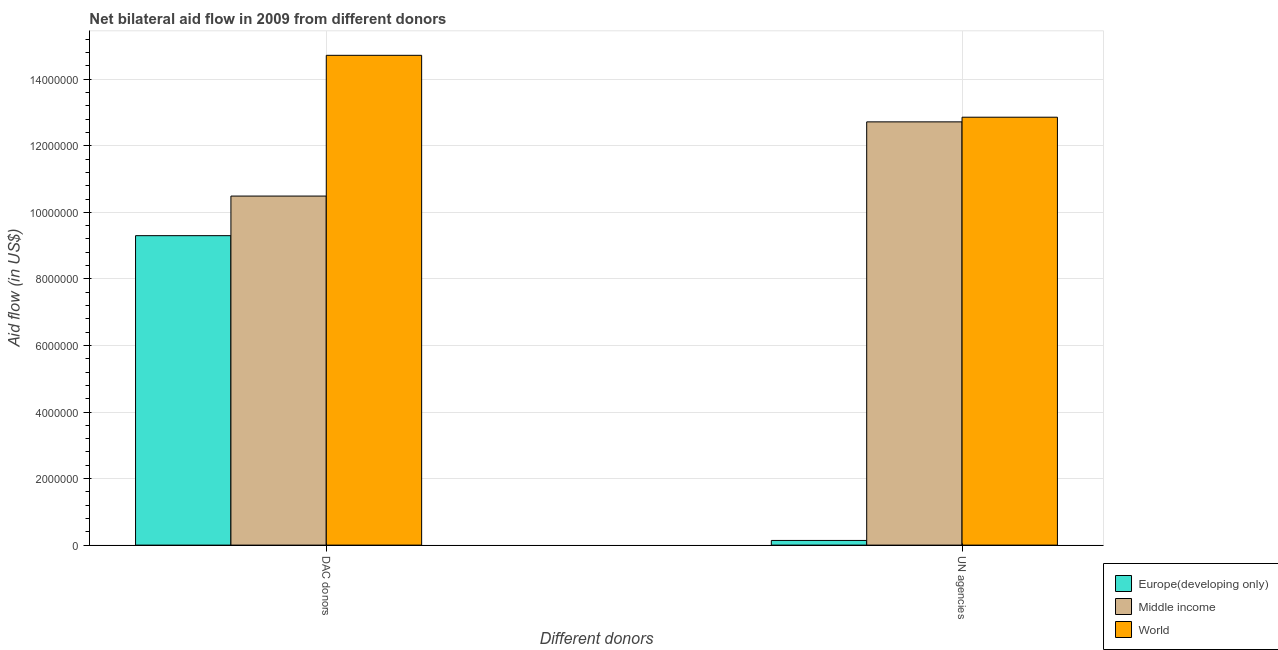How many groups of bars are there?
Your response must be concise. 2. Are the number of bars per tick equal to the number of legend labels?
Make the answer very short. Yes. How many bars are there on the 1st tick from the left?
Offer a terse response. 3. How many bars are there on the 1st tick from the right?
Provide a short and direct response. 3. What is the label of the 2nd group of bars from the left?
Give a very brief answer. UN agencies. What is the aid flow from un agencies in Europe(developing only)?
Keep it short and to the point. 1.40e+05. Across all countries, what is the maximum aid flow from dac donors?
Provide a succinct answer. 1.47e+07. Across all countries, what is the minimum aid flow from dac donors?
Provide a short and direct response. 9.30e+06. In which country was the aid flow from un agencies minimum?
Make the answer very short. Europe(developing only). What is the total aid flow from dac donors in the graph?
Give a very brief answer. 3.45e+07. What is the difference between the aid flow from dac donors in World and that in Europe(developing only)?
Your response must be concise. 5.42e+06. What is the difference between the aid flow from dac donors in Europe(developing only) and the aid flow from un agencies in Middle income?
Keep it short and to the point. -3.42e+06. What is the average aid flow from dac donors per country?
Give a very brief answer. 1.15e+07. What is the difference between the aid flow from dac donors and aid flow from un agencies in World?
Give a very brief answer. 1.86e+06. What is the ratio of the aid flow from dac donors in World to that in Europe(developing only)?
Make the answer very short. 1.58. Is the aid flow from un agencies in World less than that in Middle income?
Offer a very short reply. No. What does the 3rd bar from the left in DAC donors represents?
Keep it short and to the point. World. What does the 1st bar from the right in DAC donors represents?
Your response must be concise. World. Are all the bars in the graph horizontal?
Your answer should be very brief. No. Are the values on the major ticks of Y-axis written in scientific E-notation?
Keep it short and to the point. No. Does the graph contain any zero values?
Offer a very short reply. No. Does the graph contain grids?
Your answer should be compact. Yes. What is the title of the graph?
Offer a very short reply. Net bilateral aid flow in 2009 from different donors. What is the label or title of the X-axis?
Your answer should be very brief. Different donors. What is the label or title of the Y-axis?
Provide a short and direct response. Aid flow (in US$). What is the Aid flow (in US$) in Europe(developing only) in DAC donors?
Offer a terse response. 9.30e+06. What is the Aid flow (in US$) of Middle income in DAC donors?
Offer a very short reply. 1.05e+07. What is the Aid flow (in US$) of World in DAC donors?
Offer a very short reply. 1.47e+07. What is the Aid flow (in US$) in Middle income in UN agencies?
Keep it short and to the point. 1.27e+07. What is the Aid flow (in US$) in World in UN agencies?
Provide a short and direct response. 1.29e+07. Across all Different donors, what is the maximum Aid flow (in US$) in Europe(developing only)?
Make the answer very short. 9.30e+06. Across all Different donors, what is the maximum Aid flow (in US$) in Middle income?
Offer a terse response. 1.27e+07. Across all Different donors, what is the maximum Aid flow (in US$) in World?
Provide a succinct answer. 1.47e+07. Across all Different donors, what is the minimum Aid flow (in US$) of Europe(developing only)?
Your answer should be very brief. 1.40e+05. Across all Different donors, what is the minimum Aid flow (in US$) in Middle income?
Provide a short and direct response. 1.05e+07. Across all Different donors, what is the minimum Aid flow (in US$) in World?
Give a very brief answer. 1.29e+07. What is the total Aid flow (in US$) of Europe(developing only) in the graph?
Make the answer very short. 9.44e+06. What is the total Aid flow (in US$) of Middle income in the graph?
Offer a terse response. 2.32e+07. What is the total Aid flow (in US$) in World in the graph?
Make the answer very short. 2.76e+07. What is the difference between the Aid flow (in US$) of Europe(developing only) in DAC donors and that in UN agencies?
Offer a very short reply. 9.16e+06. What is the difference between the Aid flow (in US$) of Middle income in DAC donors and that in UN agencies?
Provide a succinct answer. -2.23e+06. What is the difference between the Aid flow (in US$) of World in DAC donors and that in UN agencies?
Provide a succinct answer. 1.86e+06. What is the difference between the Aid flow (in US$) of Europe(developing only) in DAC donors and the Aid flow (in US$) of Middle income in UN agencies?
Provide a succinct answer. -3.42e+06. What is the difference between the Aid flow (in US$) of Europe(developing only) in DAC donors and the Aid flow (in US$) of World in UN agencies?
Offer a very short reply. -3.56e+06. What is the difference between the Aid flow (in US$) of Middle income in DAC donors and the Aid flow (in US$) of World in UN agencies?
Provide a succinct answer. -2.37e+06. What is the average Aid flow (in US$) of Europe(developing only) per Different donors?
Provide a succinct answer. 4.72e+06. What is the average Aid flow (in US$) of Middle income per Different donors?
Offer a terse response. 1.16e+07. What is the average Aid flow (in US$) of World per Different donors?
Your answer should be compact. 1.38e+07. What is the difference between the Aid flow (in US$) of Europe(developing only) and Aid flow (in US$) of Middle income in DAC donors?
Provide a short and direct response. -1.19e+06. What is the difference between the Aid flow (in US$) of Europe(developing only) and Aid flow (in US$) of World in DAC donors?
Give a very brief answer. -5.42e+06. What is the difference between the Aid flow (in US$) in Middle income and Aid flow (in US$) in World in DAC donors?
Keep it short and to the point. -4.23e+06. What is the difference between the Aid flow (in US$) of Europe(developing only) and Aid flow (in US$) of Middle income in UN agencies?
Your answer should be very brief. -1.26e+07. What is the difference between the Aid flow (in US$) in Europe(developing only) and Aid flow (in US$) in World in UN agencies?
Keep it short and to the point. -1.27e+07. What is the difference between the Aid flow (in US$) in Middle income and Aid flow (in US$) in World in UN agencies?
Your answer should be very brief. -1.40e+05. What is the ratio of the Aid flow (in US$) of Europe(developing only) in DAC donors to that in UN agencies?
Give a very brief answer. 66.43. What is the ratio of the Aid flow (in US$) of Middle income in DAC donors to that in UN agencies?
Give a very brief answer. 0.82. What is the ratio of the Aid flow (in US$) in World in DAC donors to that in UN agencies?
Give a very brief answer. 1.14. What is the difference between the highest and the second highest Aid flow (in US$) of Europe(developing only)?
Make the answer very short. 9.16e+06. What is the difference between the highest and the second highest Aid flow (in US$) of Middle income?
Your answer should be compact. 2.23e+06. What is the difference between the highest and the second highest Aid flow (in US$) in World?
Provide a short and direct response. 1.86e+06. What is the difference between the highest and the lowest Aid flow (in US$) of Europe(developing only)?
Ensure brevity in your answer.  9.16e+06. What is the difference between the highest and the lowest Aid flow (in US$) of Middle income?
Ensure brevity in your answer.  2.23e+06. What is the difference between the highest and the lowest Aid flow (in US$) in World?
Offer a very short reply. 1.86e+06. 